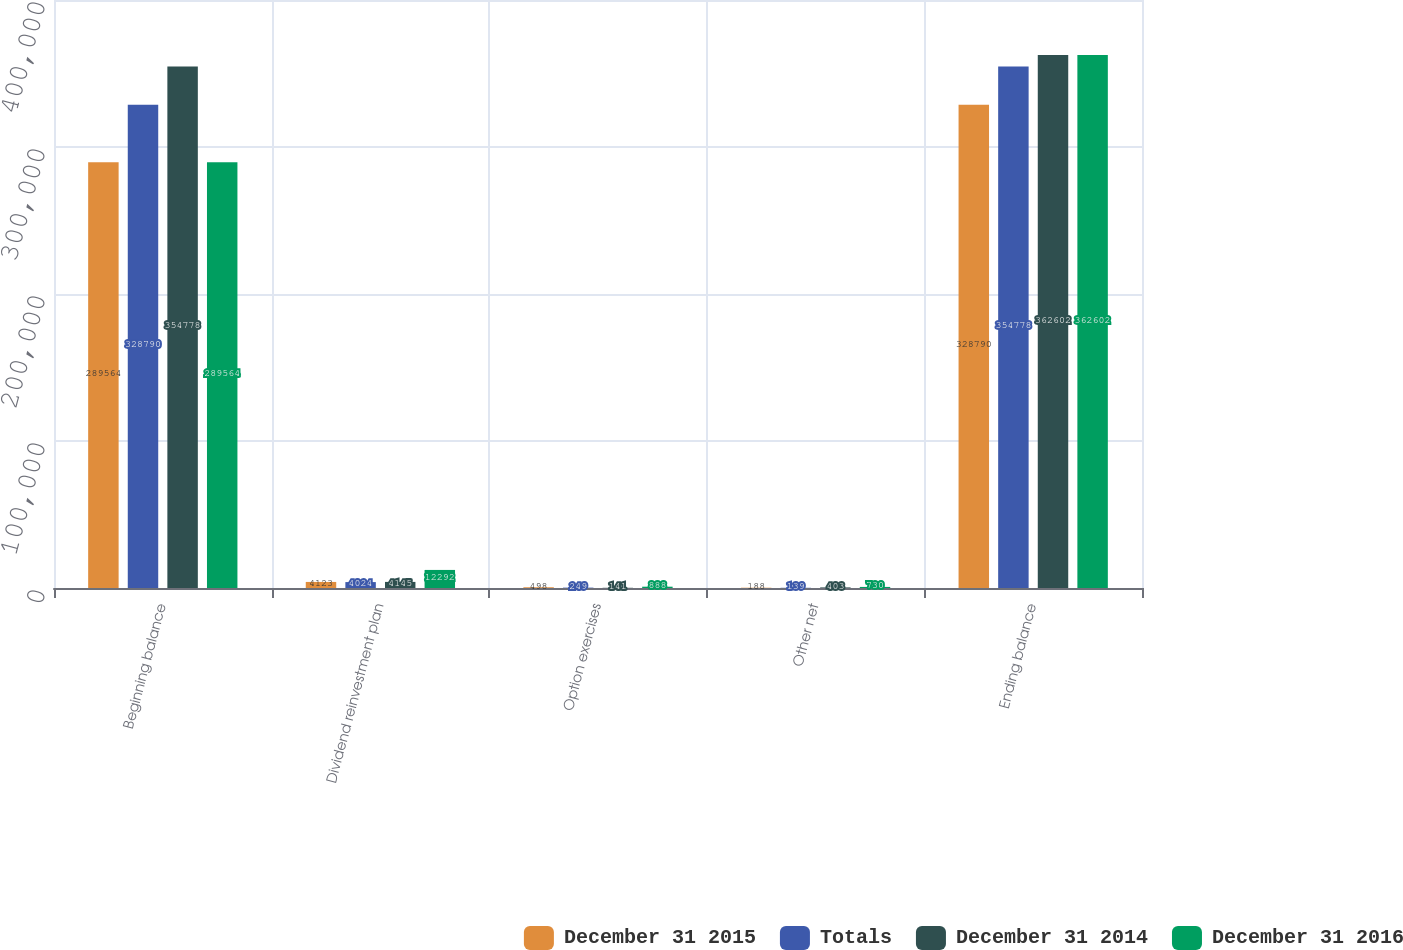<chart> <loc_0><loc_0><loc_500><loc_500><stacked_bar_chart><ecel><fcel>Beginning balance<fcel>Dividend reinvestment plan<fcel>Option exercises<fcel>Other net<fcel>Ending balance<nl><fcel>December 31 2015<fcel>289564<fcel>4123<fcel>498<fcel>188<fcel>328790<nl><fcel>Totals<fcel>328790<fcel>4024<fcel>249<fcel>139<fcel>354778<nl><fcel>December 31 2014<fcel>354778<fcel>4145<fcel>141<fcel>403<fcel>362602<nl><fcel>December 31 2016<fcel>289564<fcel>12292<fcel>888<fcel>730<fcel>362602<nl></chart> 